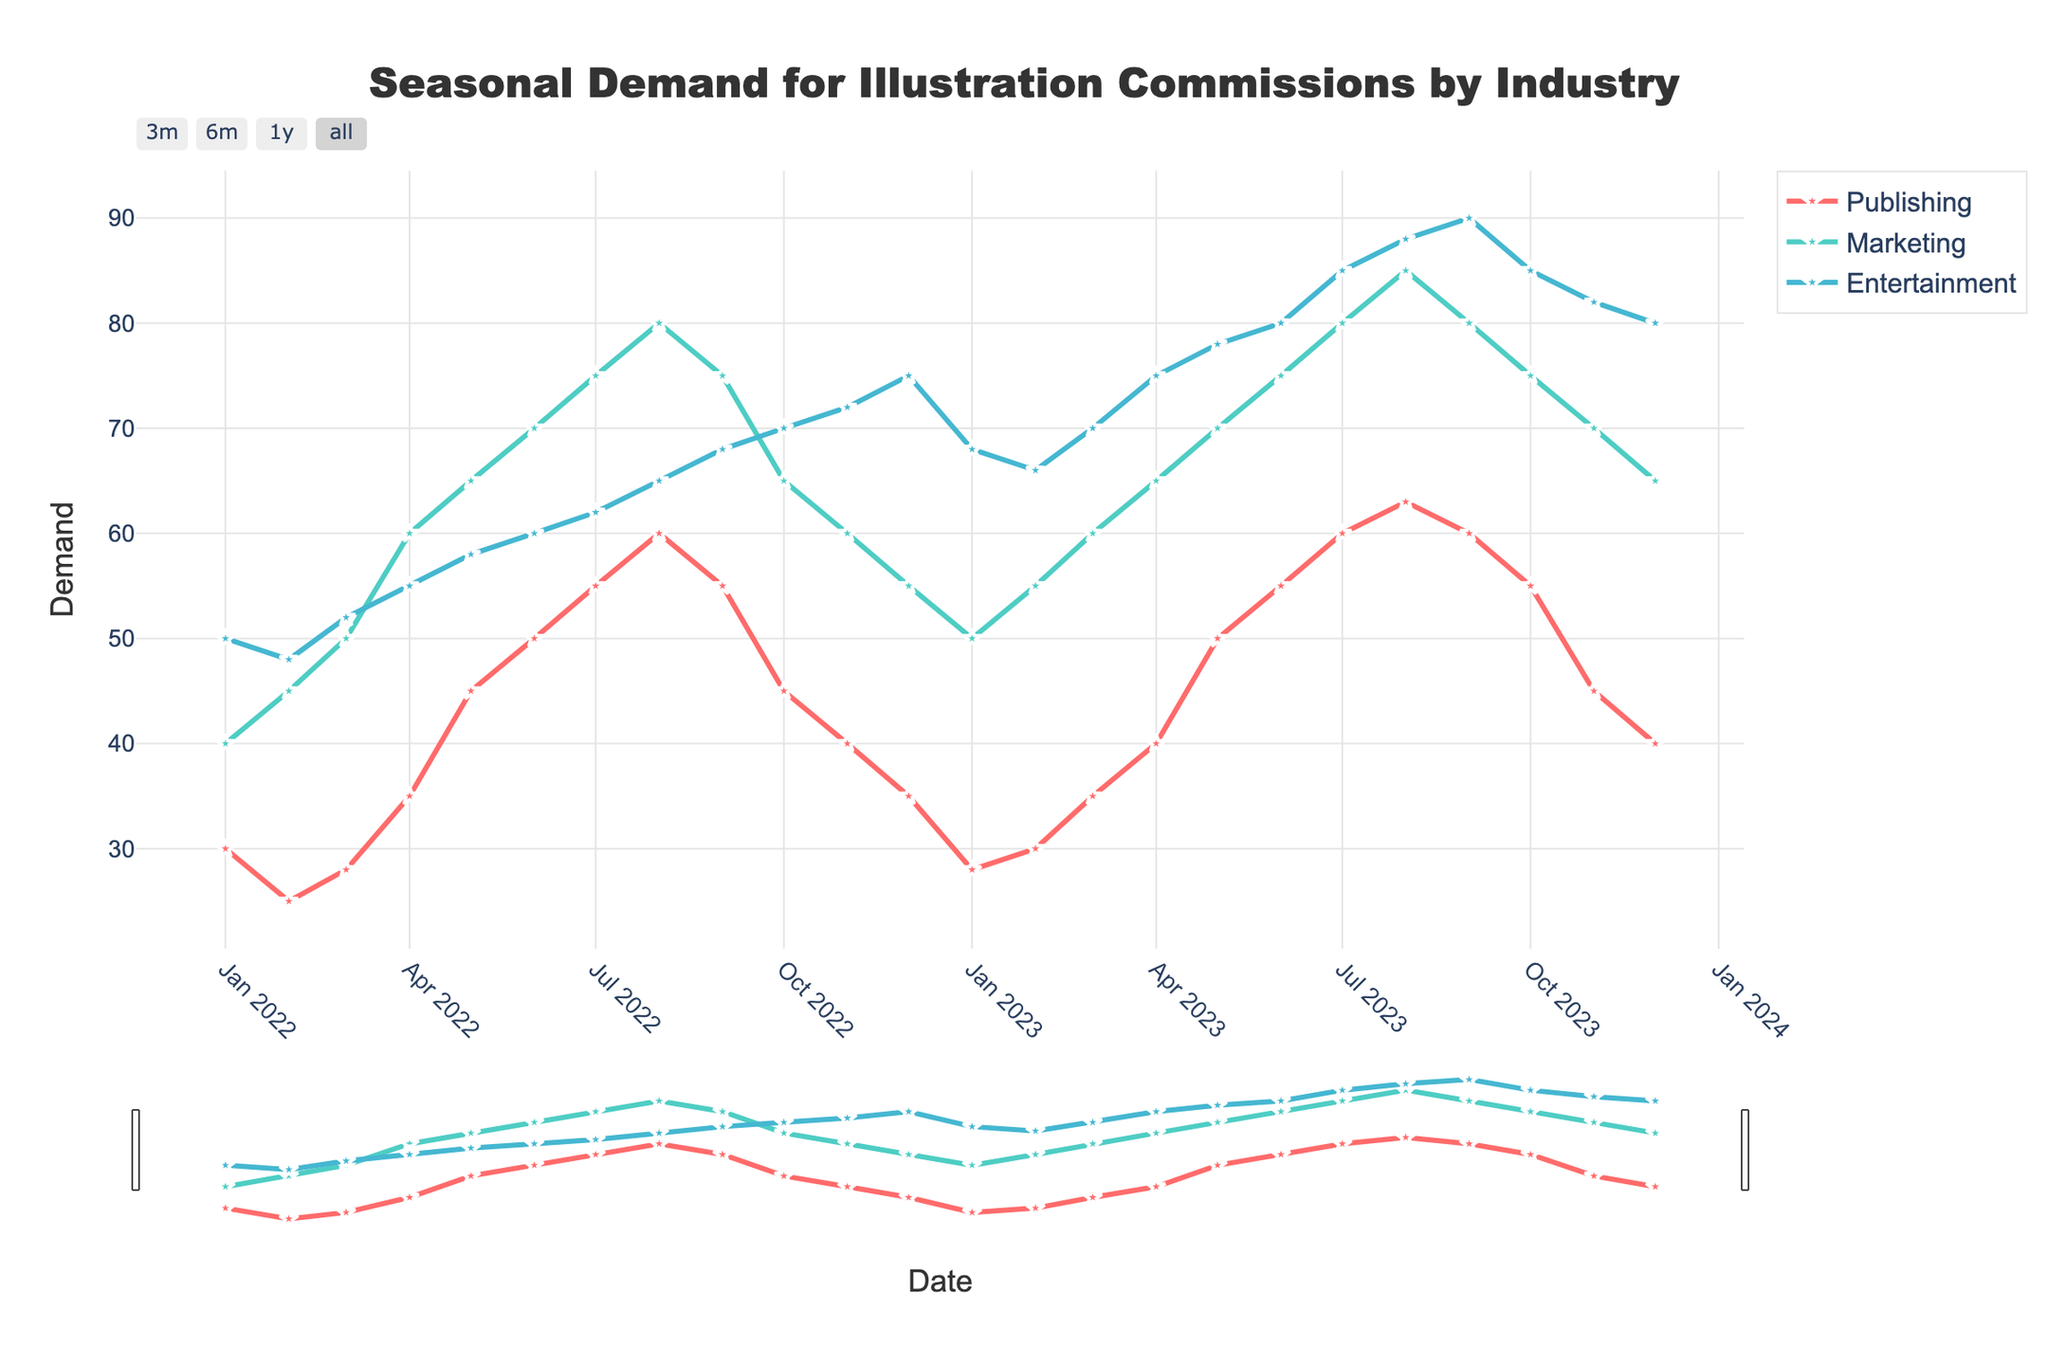Which industry has the highest demand for illustration commissions in August 2023? Looking at the figure, the demand for all three industries (Publishing, Marketing, and Entertainment) in August 2023 needs to be compared. The Entertainment industry has the highest value of 88.
Answer: Entertainment Which month experienced the lowest demand in the Publishing industry? To find the lowest demand in the Publishing industry, look at the Publishing line and identify the lowest point. This occurs in January 2023 with a demand of 28.
Answer: January 2023 How does the demand in the Marketing industry change from January 2022 to January 2023? Check the Marketing line for the values in January 2022 and January 2023, which are 40 and 50 respectively. The demand increased by (50 - 40) = 10 units.
Answer: Increased by 10 What is the average demand for illustration commissions in the Entertainment industry for the entire period? Sum all the monthly demand values in the Entertainment industry and then divide by the number of months. The total sum is 1409, and there are 24 months. So, the average is 1409 / 24 = 58.7.
Answer: 58.7 Compare the trends in demand for illustration commissions in the Publishing and Marketing industries from July to September 2023. The Publishing industry has a slight decrease from July (60) to September (60), though constant in the end. The Marketing industry shows a slight decrease from July (80) to September (80).
Answer: Stable in Publishing, slight decrease in Marketing What's the peak demand value for each industry, and in which month does it occur? Identify the highest value for each industry's line and the corresponding month. Publishing peaks in August 2023 with 63, Marketing in August 2023 with 85, and Entertainment in September 2023 with 90.
Answer: Publishing: 63 (August 2023), Marketing: 85 (August 2023), Entertainment: 90 (September 2023) What seasonal pattern can be observed in the Entertainment industry? The Entertainment industry's demand generally increases from the beginning of the year, peaks towards the end of summer/early fall, and then slightly decreases in winter before rising again.
Answer: Rising then peaking in summer/early fall How does the demand in December 2022 for the Marketing industry compare to December 2023? Look at both December 2022 and December 2023 for the Marketing industry. December 2022 has a demand of 55, while December 2023 has a demand of 65. Thus, the demand increased by (65 - 55) = 10 units.
Answer: Increased by 10 Between which two consecutive months is the biggest increase in demand for the Publishing industry observed? Look for the largest jump between two consecutive months in the Publishing industry. The biggest increase is between March 2022 (28) and April 2022 (35), which is an increase of 7 units.
Answer: March to April 2022 